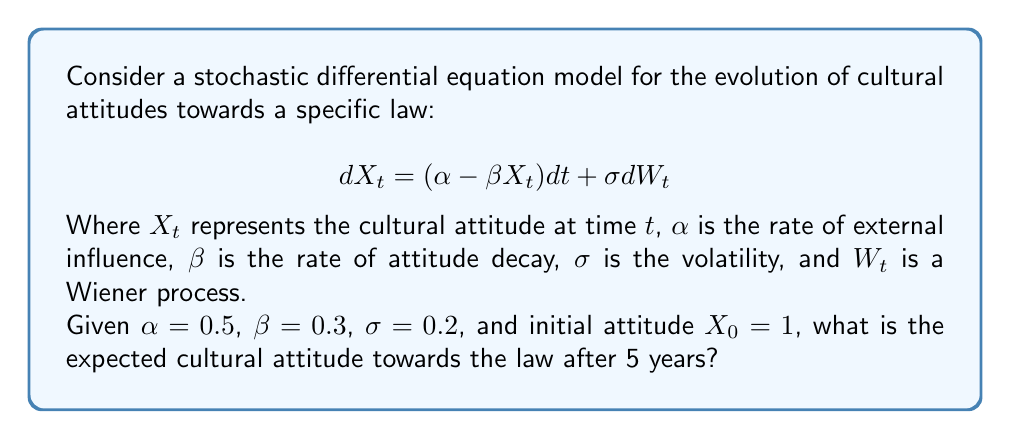Could you help me with this problem? To solve this problem, we need to follow these steps:

1) The stochastic differential equation given is an Ornstein-Uhlenbeck process. The solution to this SDE is:

   $$X_t = X_0e^{-\beta t} + \frac{\alpha}{\beta}(1-e^{-\beta t}) + \sigma e^{-\beta t}\int_0^t e^{\beta s} dW_s$$

2) The expected value of the integral term is zero, so the expected value of $X_t$ is:

   $$E[X_t] = X_0e^{-\beta t} + \frac{\alpha}{\beta}(1-e^{-\beta t})$$

3) Now, let's substitute the given values:
   $X_0 = 1$, $\alpha = 0.5$, $\beta = 0.3$, $t = 5$

4) Calculate $\frac{\alpha}{\beta}$:
   $$\frac{\alpha}{\beta} = \frac{0.5}{0.3} \approx 1.6667$$

5) Calculate $e^{-\beta t}$:
   $$e^{-0.3 \cdot 5} \approx 0.2231$$

6) Now, let's substitute these values into our equation:

   $$E[X_5] = 1 \cdot 0.2231 + 1.6667(1-0.2231)$$

7) Simplify:
   $$E[X_5] = 0.2231 + 1.6667 \cdot 0.7769 = 0.2231 + 1.2948 = 1.5179$$

Therefore, the expected cultural attitude towards the law after 5 years is approximately 1.5179.
Answer: 1.5179 